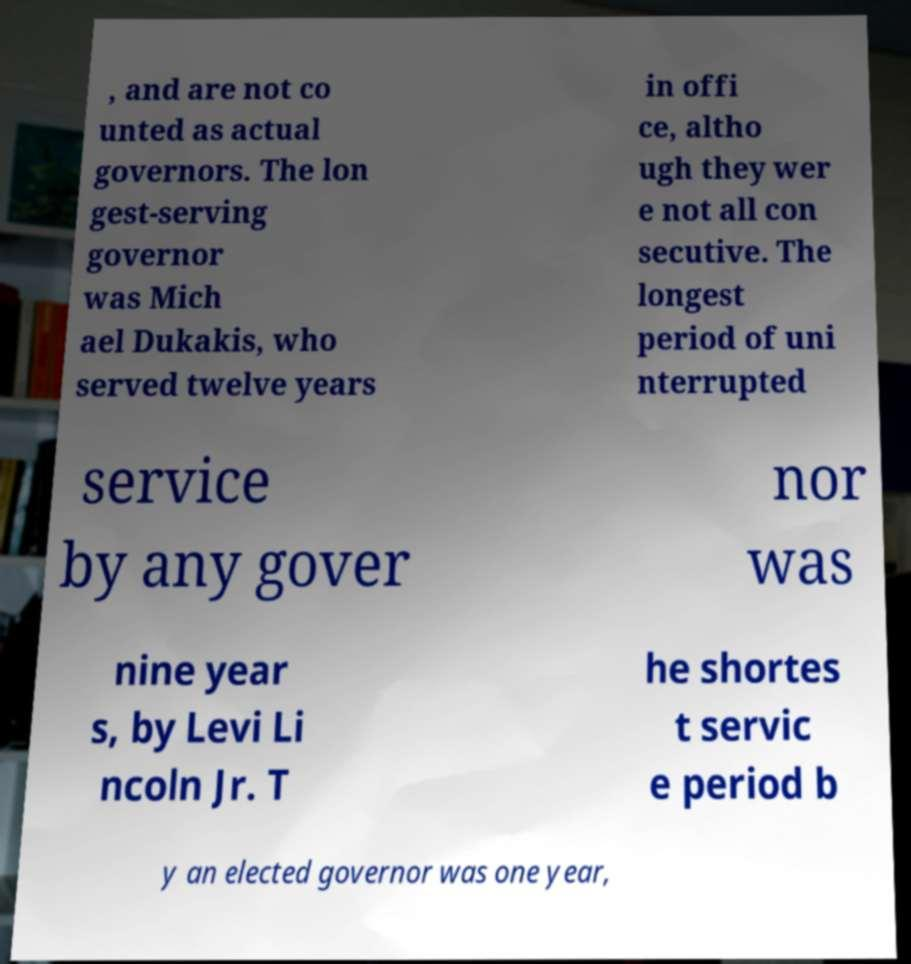Can you read and provide the text displayed in the image?This photo seems to have some interesting text. Can you extract and type it out for me? , and are not co unted as actual governors. The lon gest-serving governor was Mich ael Dukakis, who served twelve years in offi ce, altho ugh they wer e not all con secutive. The longest period of uni nterrupted service by any gover nor was nine year s, by Levi Li ncoln Jr. T he shortes t servic e period b y an elected governor was one year, 